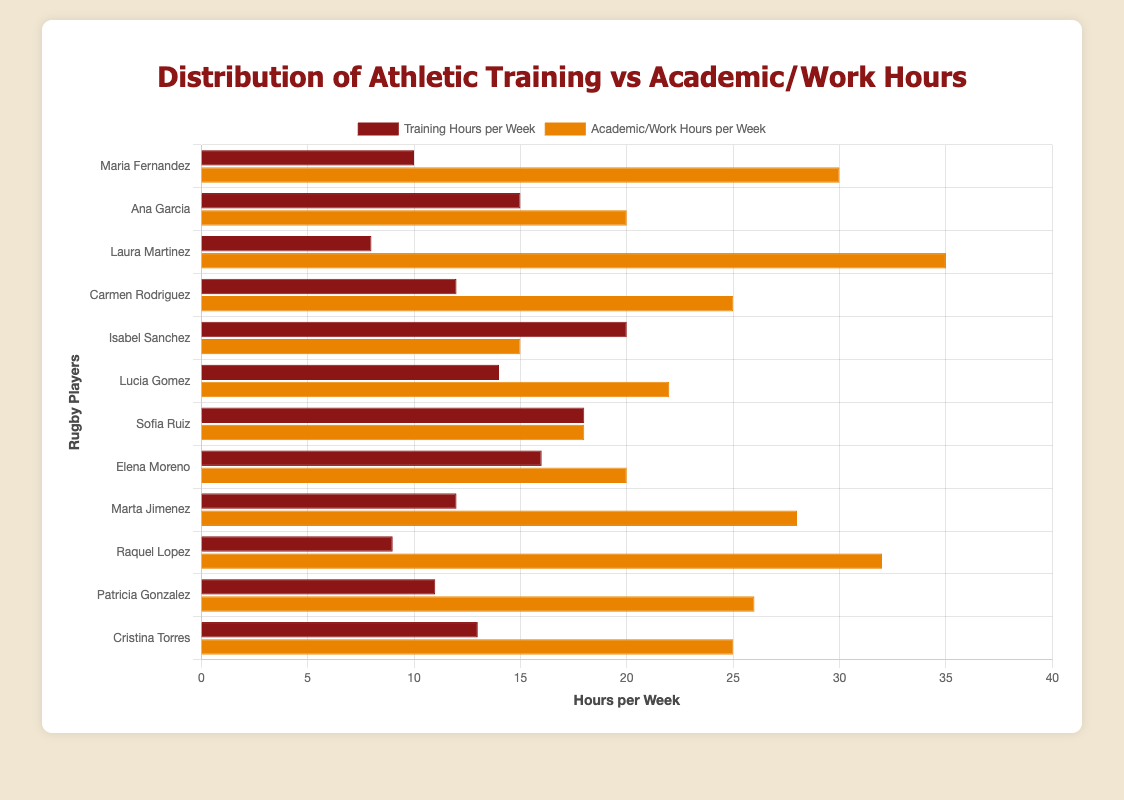Which player spends the most hours on training per week? By visually inspecting the bars, Isabel Sanchez has the longest bar for training hours.
Answer: Isabel Sanchez Who spends more hours on academic/work activities: Carmen Rodriguez or Cristina Torres? Compare the lengths of the academic/work hours bars. Cristina Torres' bar is slightly longer than Carmen Rodriguez's bar.
Answer: Cristina Torres What's the difference in training hours between Sofia Ruiz and Laura Martinez? Calculate the difference between Sofia Ruiz's 18 training hours and Laura Martinez's 8 training hours.
Answer: 10 Which player has the most balanced distribution between training and academic/work hours? Look for players with the most similar-length bars. Sofia Ruiz's 18 training hours and 18 academic/work hours are the closest match.
Answer: Sofia Ruiz Who has the longest combined training and academic/work hours? Sum the hours for each player and find the maximum. Maria Fernandez has the highest combined amount (10 + 30 = 40).
Answer: Maria Fernandez How many players train more than 12 hours per week? Count the players with training bars greater than 12. There are 7 players: Ana Garcia, Isabel Sanchez, Lucia Gomez, Sofia Ruiz, Elena Moreno, Marta Jimenez, and Cristina Torres.
Answer: 7 What's the sum of academic/work hours for Raquel Lopez and Marta Jimenez? Add Raquel Lopez's and Marta Jimenez's academic/work hours: 32 + 28 = 60.
Answer: 60 Who has a greater difference between academic/work hours and training hours, Ana Garcia or Isabel Sanchez? Calculate the differences: Ana Garcia (20 - 15 = 5) and Isabel Sanchez (15 - 20 = -5). Ana Garcia has a greater difference in absolute terms (5 vs. 5).
Answer: Equal Who spends more time training relative to academic/work hours, Isabel Sanchez or Carmen Rodriguez? Calculate the ratios: Isabel Sanchez (20/15 = 1.33), and Carmen Rodriguez (12/25 = 0.48). Compare the two ratios.
Answer: Isabel Sanchez What's the average academic/work hours for the players training more than 15 hours per week? Identify the players training more than 15 hours: Isabel Sanchez, Sofia Ruiz, Elena Moreno. Calculate their average academic/work hours: (15 + 18 + 20)/3 = 17.67.
Answer: 17.67 